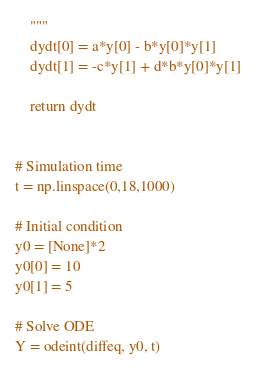<code> <loc_0><loc_0><loc_500><loc_500><_Python_>    """
    dydt[0] = a*y[0] - b*y[0]*y[1]
    dydt[1] = -c*y[1] + d*b*y[0]*y[1]

    return dydt


# Simulation time
t = np.linspace(0,18,1000)

# Initial condition
y0 = [None]*2
y0[0] = 10
y0[1] = 5

# Solve ODE
Y = odeint(diffeq, y0, t)</code> 